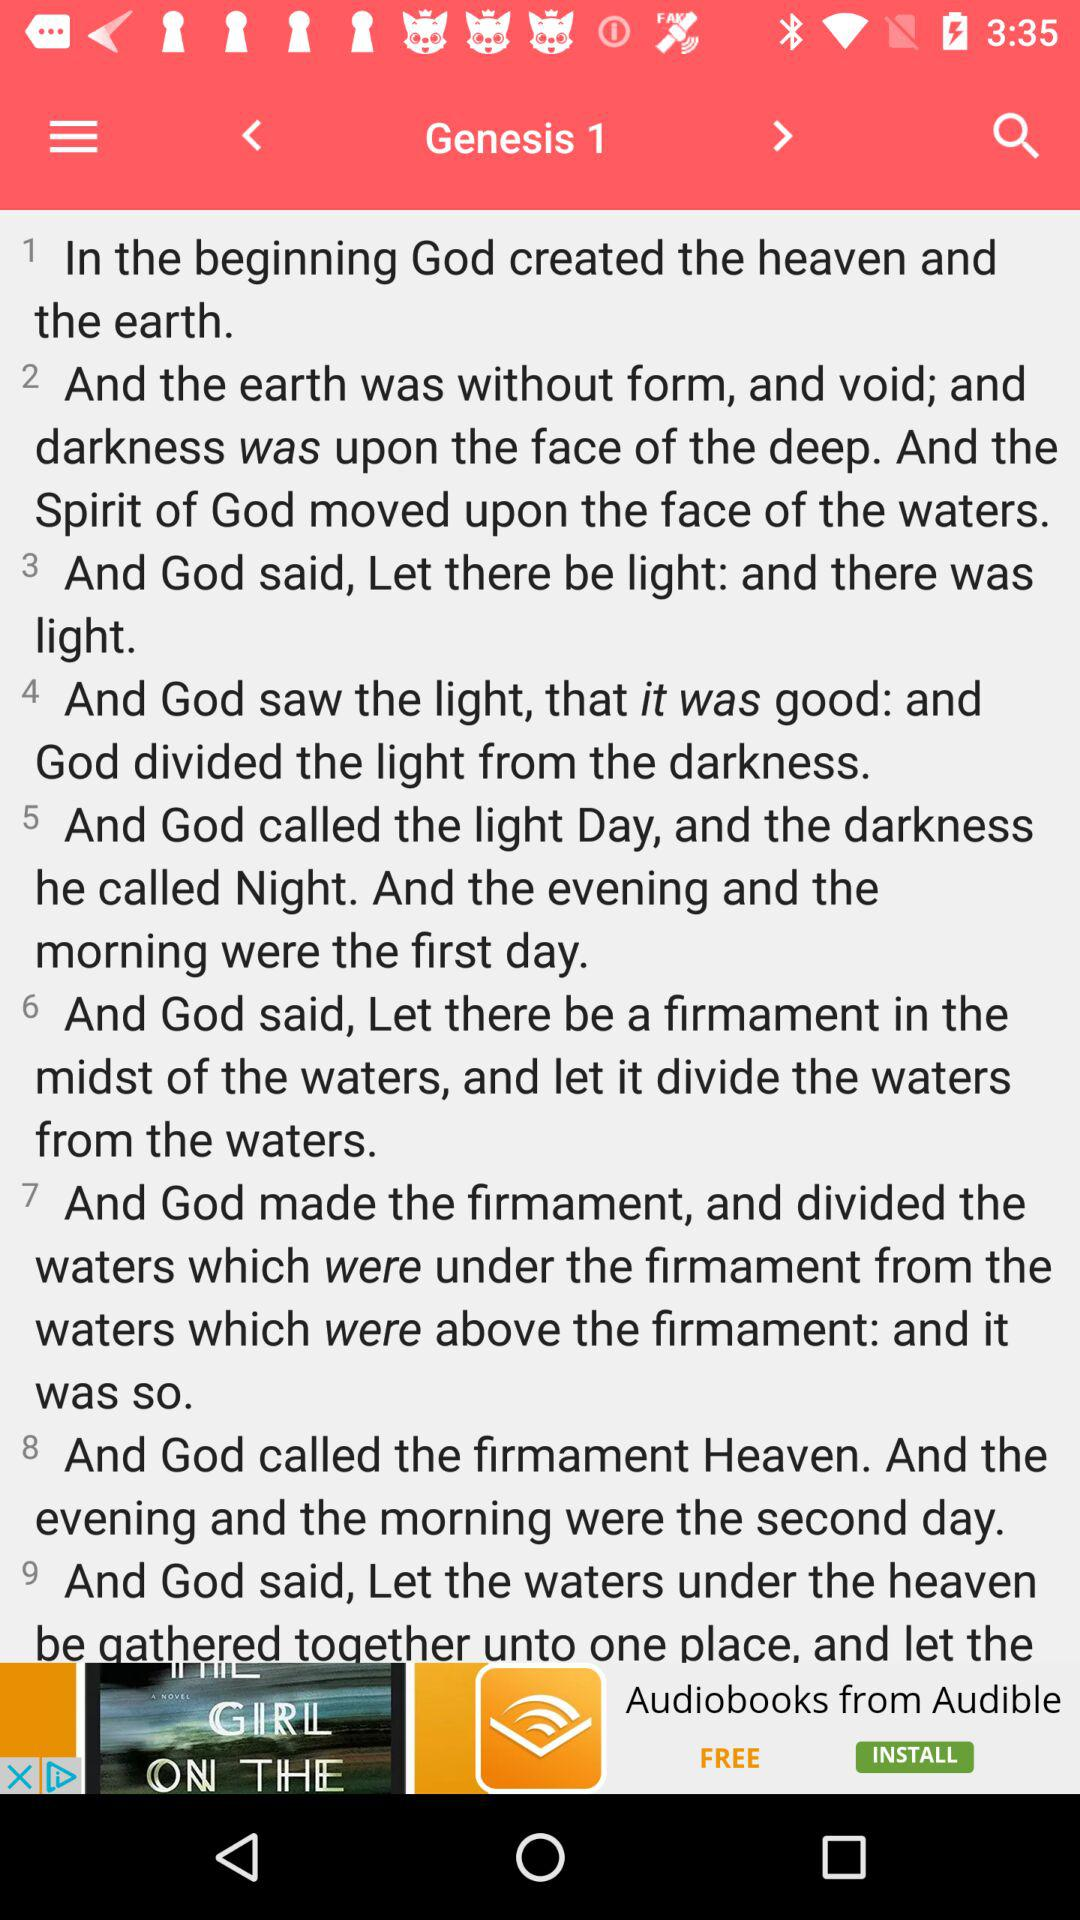Who created the heaven and the earth? The heaven and the earth were created by God. 